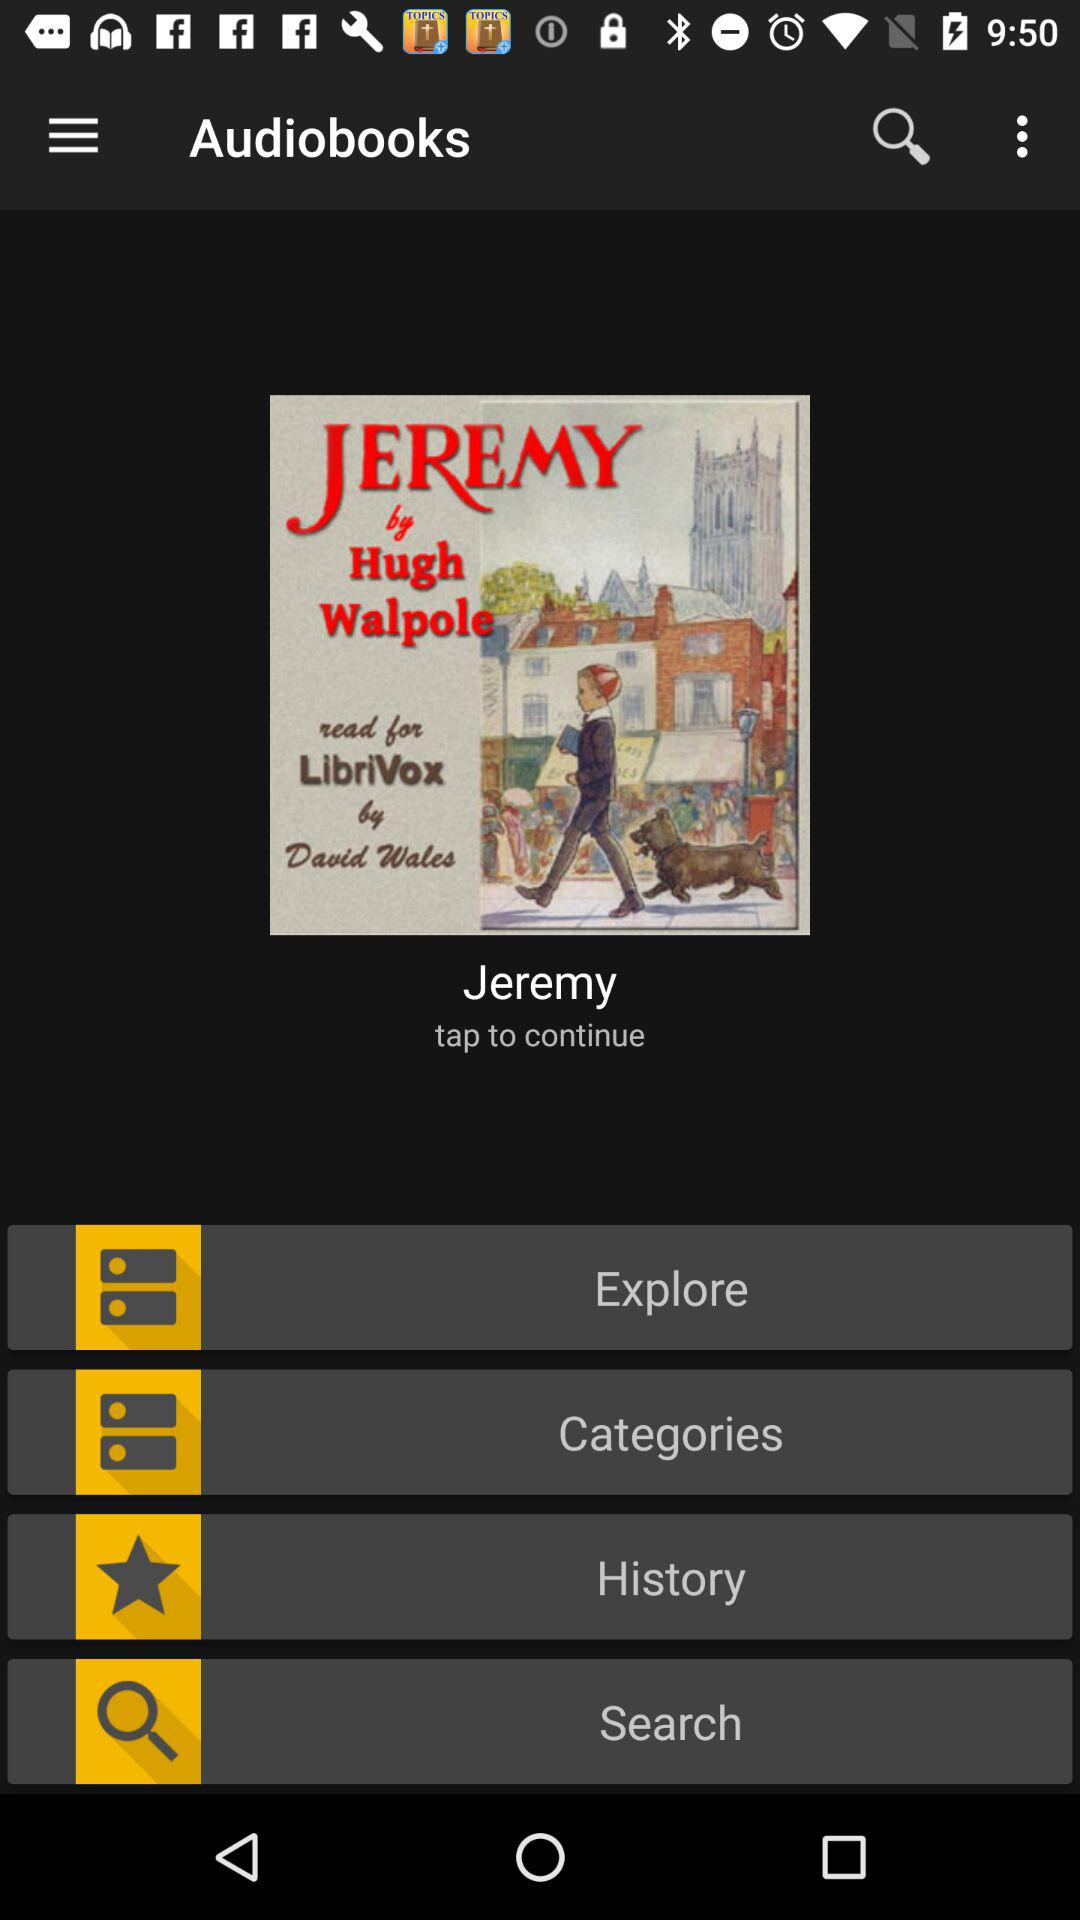What is the name of the book? The name of the book is Jeremy. 